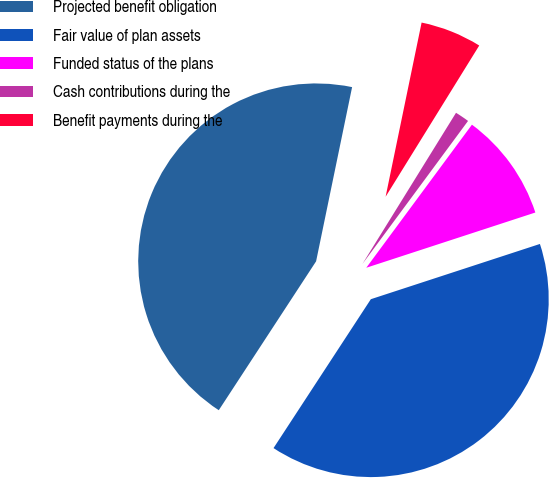<chart> <loc_0><loc_0><loc_500><loc_500><pie_chart><fcel>Projected benefit obligation<fcel>Fair value of plan assets<fcel>Funded status of the plans<fcel>Cash contributions during the<fcel>Benefit payments during the<nl><fcel>44.03%<fcel>39.24%<fcel>9.85%<fcel>1.3%<fcel>5.58%<nl></chart> 